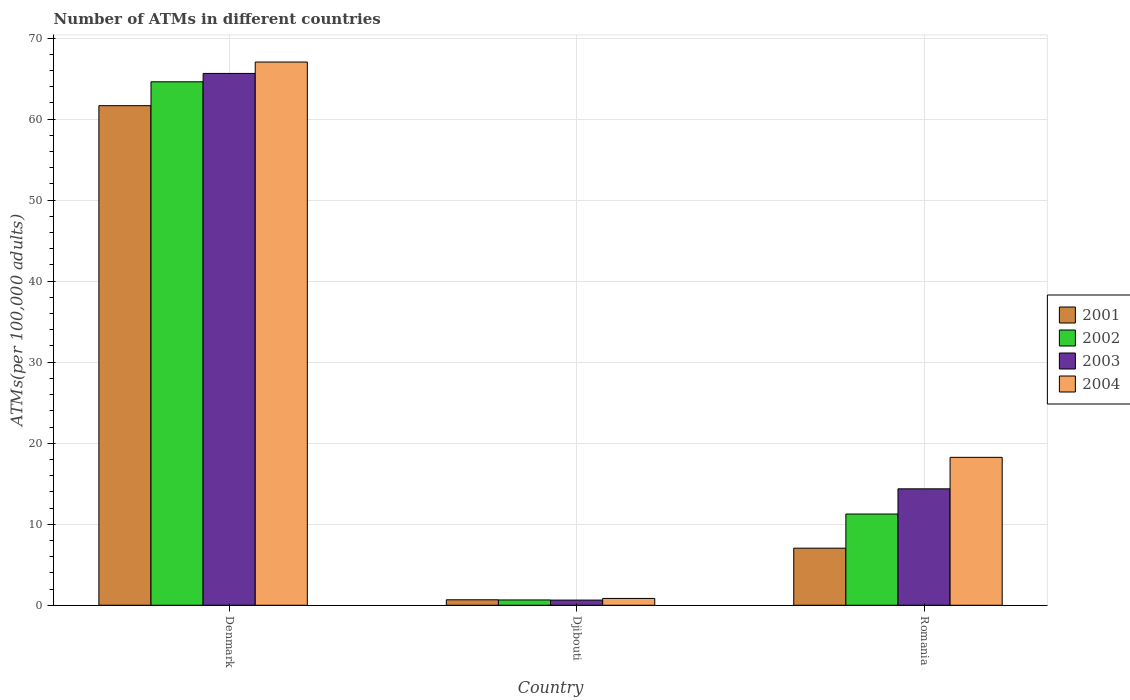How many different coloured bars are there?
Your response must be concise. 4. Are the number of bars on each tick of the X-axis equal?
Provide a succinct answer. Yes. What is the label of the 2nd group of bars from the left?
Keep it short and to the point. Djibouti. What is the number of ATMs in 2003 in Denmark?
Offer a very short reply. 65.64. Across all countries, what is the maximum number of ATMs in 2004?
Keep it short and to the point. 67.04. Across all countries, what is the minimum number of ATMs in 2004?
Provide a short and direct response. 0.84. In which country was the number of ATMs in 2003 minimum?
Provide a short and direct response. Djibouti. What is the total number of ATMs in 2003 in the graph?
Your response must be concise. 80.65. What is the difference between the number of ATMs in 2004 in Denmark and that in Romania?
Ensure brevity in your answer.  48.79. What is the difference between the number of ATMs in 2001 in Romania and the number of ATMs in 2003 in Djibouti?
Ensure brevity in your answer.  6.41. What is the average number of ATMs in 2002 per country?
Offer a terse response. 25.51. What is the difference between the number of ATMs of/in 2001 and number of ATMs of/in 2004 in Romania?
Keep it short and to the point. -11.21. What is the ratio of the number of ATMs in 2002 in Djibouti to that in Romania?
Your answer should be very brief. 0.06. Is the number of ATMs in 2001 in Denmark less than that in Romania?
Ensure brevity in your answer.  No. Is the difference between the number of ATMs in 2001 in Denmark and Djibouti greater than the difference between the number of ATMs in 2004 in Denmark and Djibouti?
Give a very brief answer. No. What is the difference between the highest and the second highest number of ATMs in 2004?
Provide a succinct answer. -17.41. What is the difference between the highest and the lowest number of ATMs in 2002?
Provide a succinct answer. 63.95. In how many countries, is the number of ATMs in 2002 greater than the average number of ATMs in 2002 taken over all countries?
Ensure brevity in your answer.  1. What does the 2nd bar from the left in Djibouti represents?
Provide a short and direct response. 2002. What does the 3rd bar from the right in Denmark represents?
Provide a short and direct response. 2002. How many countries are there in the graph?
Provide a succinct answer. 3. What is the difference between two consecutive major ticks on the Y-axis?
Make the answer very short. 10. Does the graph contain grids?
Your response must be concise. Yes. How many legend labels are there?
Provide a short and direct response. 4. How are the legend labels stacked?
Provide a short and direct response. Vertical. What is the title of the graph?
Keep it short and to the point. Number of ATMs in different countries. Does "2001" appear as one of the legend labels in the graph?
Provide a short and direct response. Yes. What is the label or title of the X-axis?
Make the answer very short. Country. What is the label or title of the Y-axis?
Make the answer very short. ATMs(per 100,0 adults). What is the ATMs(per 100,000 adults) of 2001 in Denmark?
Provide a short and direct response. 61.66. What is the ATMs(per 100,000 adults) of 2002 in Denmark?
Offer a very short reply. 64.61. What is the ATMs(per 100,000 adults) in 2003 in Denmark?
Keep it short and to the point. 65.64. What is the ATMs(per 100,000 adults) in 2004 in Denmark?
Your answer should be very brief. 67.04. What is the ATMs(per 100,000 adults) of 2001 in Djibouti?
Offer a very short reply. 0.68. What is the ATMs(per 100,000 adults) of 2002 in Djibouti?
Offer a very short reply. 0.66. What is the ATMs(per 100,000 adults) in 2003 in Djibouti?
Make the answer very short. 0.64. What is the ATMs(per 100,000 adults) in 2004 in Djibouti?
Give a very brief answer. 0.84. What is the ATMs(per 100,000 adults) in 2001 in Romania?
Offer a very short reply. 7.04. What is the ATMs(per 100,000 adults) of 2002 in Romania?
Make the answer very short. 11.26. What is the ATMs(per 100,000 adults) of 2003 in Romania?
Offer a terse response. 14.37. What is the ATMs(per 100,000 adults) of 2004 in Romania?
Your answer should be very brief. 18.26. Across all countries, what is the maximum ATMs(per 100,000 adults) in 2001?
Offer a terse response. 61.66. Across all countries, what is the maximum ATMs(per 100,000 adults) of 2002?
Give a very brief answer. 64.61. Across all countries, what is the maximum ATMs(per 100,000 adults) in 2003?
Your answer should be very brief. 65.64. Across all countries, what is the maximum ATMs(per 100,000 adults) of 2004?
Offer a very short reply. 67.04. Across all countries, what is the minimum ATMs(per 100,000 adults) in 2001?
Offer a very short reply. 0.68. Across all countries, what is the minimum ATMs(per 100,000 adults) of 2002?
Give a very brief answer. 0.66. Across all countries, what is the minimum ATMs(per 100,000 adults) in 2003?
Offer a very short reply. 0.64. Across all countries, what is the minimum ATMs(per 100,000 adults) of 2004?
Offer a very short reply. 0.84. What is the total ATMs(per 100,000 adults) of 2001 in the graph?
Give a very brief answer. 69.38. What is the total ATMs(per 100,000 adults) in 2002 in the graph?
Provide a succinct answer. 76.52. What is the total ATMs(per 100,000 adults) in 2003 in the graph?
Offer a terse response. 80.65. What is the total ATMs(per 100,000 adults) in 2004 in the graph?
Offer a very short reply. 86.14. What is the difference between the ATMs(per 100,000 adults) in 2001 in Denmark and that in Djibouti?
Provide a short and direct response. 60.98. What is the difference between the ATMs(per 100,000 adults) in 2002 in Denmark and that in Djibouti?
Your answer should be very brief. 63.95. What is the difference between the ATMs(per 100,000 adults) in 2003 in Denmark and that in Djibouti?
Give a very brief answer. 65. What is the difference between the ATMs(per 100,000 adults) of 2004 in Denmark and that in Djibouti?
Give a very brief answer. 66.2. What is the difference between the ATMs(per 100,000 adults) of 2001 in Denmark and that in Romania?
Offer a terse response. 54.61. What is the difference between the ATMs(per 100,000 adults) in 2002 in Denmark and that in Romania?
Provide a short and direct response. 53.35. What is the difference between the ATMs(per 100,000 adults) in 2003 in Denmark and that in Romania?
Keep it short and to the point. 51.27. What is the difference between the ATMs(per 100,000 adults) in 2004 in Denmark and that in Romania?
Provide a short and direct response. 48.79. What is the difference between the ATMs(per 100,000 adults) of 2001 in Djibouti and that in Romania?
Your response must be concise. -6.37. What is the difference between the ATMs(per 100,000 adults) of 2002 in Djibouti and that in Romania?
Give a very brief answer. -10.6. What is the difference between the ATMs(per 100,000 adults) of 2003 in Djibouti and that in Romania?
Your answer should be compact. -13.73. What is the difference between the ATMs(per 100,000 adults) in 2004 in Djibouti and that in Romania?
Offer a very short reply. -17.41. What is the difference between the ATMs(per 100,000 adults) of 2001 in Denmark and the ATMs(per 100,000 adults) of 2002 in Djibouti?
Ensure brevity in your answer.  61. What is the difference between the ATMs(per 100,000 adults) of 2001 in Denmark and the ATMs(per 100,000 adults) of 2003 in Djibouti?
Offer a very short reply. 61.02. What is the difference between the ATMs(per 100,000 adults) of 2001 in Denmark and the ATMs(per 100,000 adults) of 2004 in Djibouti?
Keep it short and to the point. 60.81. What is the difference between the ATMs(per 100,000 adults) in 2002 in Denmark and the ATMs(per 100,000 adults) in 2003 in Djibouti?
Your answer should be compact. 63.97. What is the difference between the ATMs(per 100,000 adults) in 2002 in Denmark and the ATMs(per 100,000 adults) in 2004 in Djibouti?
Your answer should be compact. 63.76. What is the difference between the ATMs(per 100,000 adults) of 2003 in Denmark and the ATMs(per 100,000 adults) of 2004 in Djibouti?
Provide a succinct answer. 64.79. What is the difference between the ATMs(per 100,000 adults) in 2001 in Denmark and the ATMs(per 100,000 adults) in 2002 in Romania?
Your response must be concise. 50.4. What is the difference between the ATMs(per 100,000 adults) of 2001 in Denmark and the ATMs(per 100,000 adults) of 2003 in Romania?
Offer a terse response. 47.29. What is the difference between the ATMs(per 100,000 adults) in 2001 in Denmark and the ATMs(per 100,000 adults) in 2004 in Romania?
Keep it short and to the point. 43.4. What is the difference between the ATMs(per 100,000 adults) in 2002 in Denmark and the ATMs(per 100,000 adults) in 2003 in Romania?
Ensure brevity in your answer.  50.24. What is the difference between the ATMs(per 100,000 adults) in 2002 in Denmark and the ATMs(per 100,000 adults) in 2004 in Romania?
Give a very brief answer. 46.35. What is the difference between the ATMs(per 100,000 adults) in 2003 in Denmark and the ATMs(per 100,000 adults) in 2004 in Romania?
Your answer should be very brief. 47.38. What is the difference between the ATMs(per 100,000 adults) of 2001 in Djibouti and the ATMs(per 100,000 adults) of 2002 in Romania?
Offer a terse response. -10.58. What is the difference between the ATMs(per 100,000 adults) in 2001 in Djibouti and the ATMs(per 100,000 adults) in 2003 in Romania?
Your answer should be very brief. -13.69. What is the difference between the ATMs(per 100,000 adults) in 2001 in Djibouti and the ATMs(per 100,000 adults) in 2004 in Romania?
Your response must be concise. -17.58. What is the difference between the ATMs(per 100,000 adults) in 2002 in Djibouti and the ATMs(per 100,000 adults) in 2003 in Romania?
Your answer should be compact. -13.71. What is the difference between the ATMs(per 100,000 adults) in 2002 in Djibouti and the ATMs(per 100,000 adults) in 2004 in Romania?
Provide a succinct answer. -17.6. What is the difference between the ATMs(per 100,000 adults) of 2003 in Djibouti and the ATMs(per 100,000 adults) of 2004 in Romania?
Your answer should be compact. -17.62. What is the average ATMs(per 100,000 adults) in 2001 per country?
Offer a very short reply. 23.13. What is the average ATMs(per 100,000 adults) in 2002 per country?
Your response must be concise. 25.51. What is the average ATMs(per 100,000 adults) of 2003 per country?
Your answer should be very brief. 26.88. What is the average ATMs(per 100,000 adults) in 2004 per country?
Ensure brevity in your answer.  28.71. What is the difference between the ATMs(per 100,000 adults) in 2001 and ATMs(per 100,000 adults) in 2002 in Denmark?
Your response must be concise. -2.95. What is the difference between the ATMs(per 100,000 adults) in 2001 and ATMs(per 100,000 adults) in 2003 in Denmark?
Your response must be concise. -3.98. What is the difference between the ATMs(per 100,000 adults) in 2001 and ATMs(per 100,000 adults) in 2004 in Denmark?
Offer a very short reply. -5.39. What is the difference between the ATMs(per 100,000 adults) of 2002 and ATMs(per 100,000 adults) of 2003 in Denmark?
Keep it short and to the point. -1.03. What is the difference between the ATMs(per 100,000 adults) in 2002 and ATMs(per 100,000 adults) in 2004 in Denmark?
Your answer should be very brief. -2.44. What is the difference between the ATMs(per 100,000 adults) of 2003 and ATMs(per 100,000 adults) of 2004 in Denmark?
Offer a terse response. -1.41. What is the difference between the ATMs(per 100,000 adults) in 2001 and ATMs(per 100,000 adults) in 2002 in Djibouti?
Give a very brief answer. 0.02. What is the difference between the ATMs(per 100,000 adults) of 2001 and ATMs(per 100,000 adults) of 2003 in Djibouti?
Offer a terse response. 0.04. What is the difference between the ATMs(per 100,000 adults) in 2001 and ATMs(per 100,000 adults) in 2004 in Djibouti?
Give a very brief answer. -0.17. What is the difference between the ATMs(per 100,000 adults) of 2002 and ATMs(per 100,000 adults) of 2003 in Djibouti?
Make the answer very short. 0.02. What is the difference between the ATMs(per 100,000 adults) of 2002 and ATMs(per 100,000 adults) of 2004 in Djibouti?
Give a very brief answer. -0.19. What is the difference between the ATMs(per 100,000 adults) of 2003 and ATMs(per 100,000 adults) of 2004 in Djibouti?
Ensure brevity in your answer.  -0.21. What is the difference between the ATMs(per 100,000 adults) of 2001 and ATMs(per 100,000 adults) of 2002 in Romania?
Offer a very short reply. -4.21. What is the difference between the ATMs(per 100,000 adults) of 2001 and ATMs(per 100,000 adults) of 2003 in Romania?
Make the answer very short. -7.32. What is the difference between the ATMs(per 100,000 adults) in 2001 and ATMs(per 100,000 adults) in 2004 in Romania?
Your response must be concise. -11.21. What is the difference between the ATMs(per 100,000 adults) in 2002 and ATMs(per 100,000 adults) in 2003 in Romania?
Make the answer very short. -3.11. What is the difference between the ATMs(per 100,000 adults) in 2002 and ATMs(per 100,000 adults) in 2004 in Romania?
Keep it short and to the point. -7. What is the difference between the ATMs(per 100,000 adults) of 2003 and ATMs(per 100,000 adults) of 2004 in Romania?
Offer a very short reply. -3.89. What is the ratio of the ATMs(per 100,000 adults) in 2001 in Denmark to that in Djibouti?
Ensure brevity in your answer.  91.18. What is the ratio of the ATMs(per 100,000 adults) of 2002 in Denmark to that in Djibouti?
Your answer should be very brief. 98.45. What is the ratio of the ATMs(per 100,000 adults) in 2003 in Denmark to that in Djibouti?
Provide a short and direct response. 102.88. What is the ratio of the ATMs(per 100,000 adults) of 2004 in Denmark to that in Djibouti?
Give a very brief answer. 79.46. What is the ratio of the ATMs(per 100,000 adults) of 2001 in Denmark to that in Romania?
Give a very brief answer. 8.75. What is the ratio of the ATMs(per 100,000 adults) of 2002 in Denmark to that in Romania?
Offer a very short reply. 5.74. What is the ratio of the ATMs(per 100,000 adults) in 2003 in Denmark to that in Romania?
Your response must be concise. 4.57. What is the ratio of the ATMs(per 100,000 adults) of 2004 in Denmark to that in Romania?
Provide a short and direct response. 3.67. What is the ratio of the ATMs(per 100,000 adults) in 2001 in Djibouti to that in Romania?
Your answer should be compact. 0.1. What is the ratio of the ATMs(per 100,000 adults) of 2002 in Djibouti to that in Romania?
Offer a very short reply. 0.06. What is the ratio of the ATMs(per 100,000 adults) of 2003 in Djibouti to that in Romania?
Your answer should be compact. 0.04. What is the ratio of the ATMs(per 100,000 adults) of 2004 in Djibouti to that in Romania?
Your answer should be very brief. 0.05. What is the difference between the highest and the second highest ATMs(per 100,000 adults) in 2001?
Your answer should be compact. 54.61. What is the difference between the highest and the second highest ATMs(per 100,000 adults) of 2002?
Your answer should be compact. 53.35. What is the difference between the highest and the second highest ATMs(per 100,000 adults) in 2003?
Ensure brevity in your answer.  51.27. What is the difference between the highest and the second highest ATMs(per 100,000 adults) in 2004?
Offer a terse response. 48.79. What is the difference between the highest and the lowest ATMs(per 100,000 adults) in 2001?
Your answer should be compact. 60.98. What is the difference between the highest and the lowest ATMs(per 100,000 adults) in 2002?
Offer a terse response. 63.95. What is the difference between the highest and the lowest ATMs(per 100,000 adults) of 2003?
Ensure brevity in your answer.  65. What is the difference between the highest and the lowest ATMs(per 100,000 adults) in 2004?
Provide a short and direct response. 66.2. 